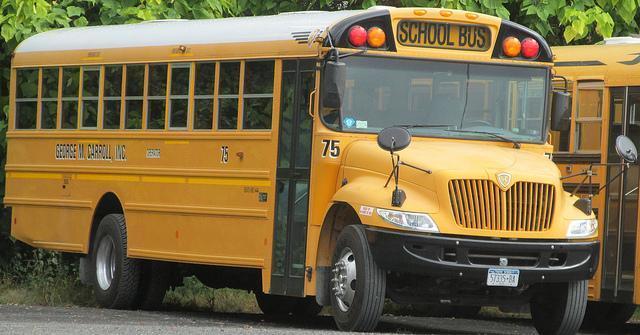How many windows are on the right side of the bus?
Give a very brief answer. 11. How many buses are there?
Give a very brief answer. 2. How many giraffes are there in the picture?
Give a very brief answer. 0. 